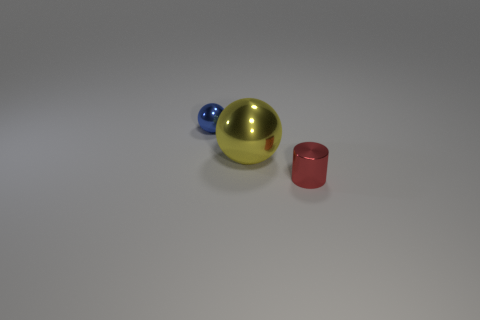There is a object that is to the right of the small ball and left of the red metal thing; how big is it?
Make the answer very short. Large. Are there fewer balls in front of the red thing than yellow metallic objects in front of the yellow metallic thing?
Make the answer very short. No. How many tiny balls are made of the same material as the small red thing?
Your answer should be compact. 1. Are there any tiny metallic cylinders that are on the right side of the ball that is on the right side of the tiny metal object to the left of the yellow ball?
Your answer should be very brief. Yes. What number of balls are either big cyan matte things or big shiny things?
Keep it short and to the point. 1. There is a blue metal object; is it the same shape as the big yellow thing that is in front of the small blue thing?
Offer a very short reply. Yes. Is the number of red cylinders left of the small ball less than the number of big blue shiny spheres?
Your response must be concise. No. Are there any blue objects on the right side of the tiny blue shiny object?
Provide a short and direct response. No. Is there another metal object of the same shape as the large metal object?
Your response must be concise. Yes. There is a red thing that is the same size as the blue metallic thing; what is its shape?
Provide a succinct answer. Cylinder. 